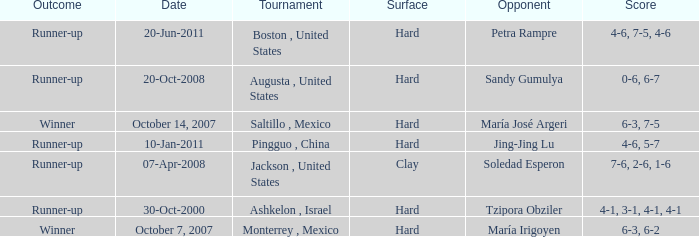What was the outcome when Jing-Jing Lu was the opponent? Runner-up. 